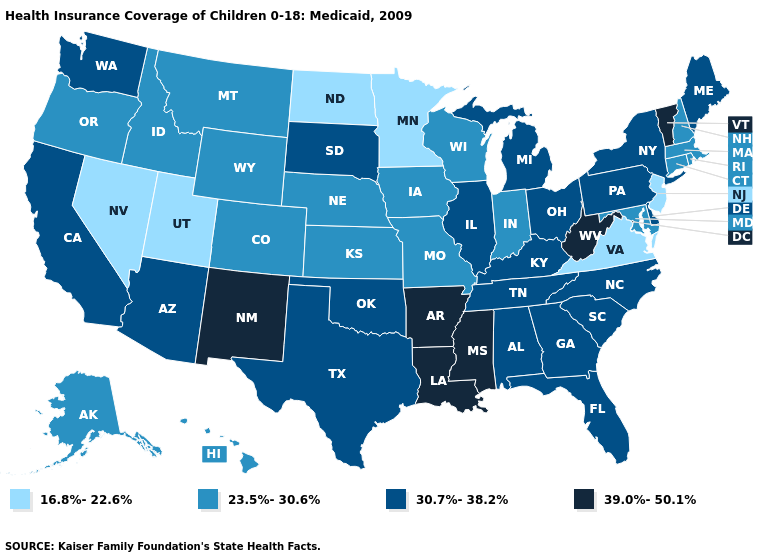Does the map have missing data?
Quick response, please. No. Name the states that have a value in the range 16.8%-22.6%?
Short answer required. Minnesota, Nevada, New Jersey, North Dakota, Utah, Virginia. Does South Carolina have the lowest value in the USA?
Be succinct. No. Name the states that have a value in the range 23.5%-30.6%?
Concise answer only. Alaska, Colorado, Connecticut, Hawaii, Idaho, Indiana, Iowa, Kansas, Maryland, Massachusetts, Missouri, Montana, Nebraska, New Hampshire, Oregon, Rhode Island, Wisconsin, Wyoming. What is the value of Idaho?
Write a very short answer. 23.5%-30.6%. What is the highest value in states that border Kansas?
Write a very short answer. 30.7%-38.2%. Name the states that have a value in the range 30.7%-38.2%?
Write a very short answer. Alabama, Arizona, California, Delaware, Florida, Georgia, Illinois, Kentucky, Maine, Michigan, New York, North Carolina, Ohio, Oklahoma, Pennsylvania, South Carolina, South Dakota, Tennessee, Texas, Washington. How many symbols are there in the legend?
Quick response, please. 4. What is the value of Montana?
Answer briefly. 23.5%-30.6%. Name the states that have a value in the range 23.5%-30.6%?
Write a very short answer. Alaska, Colorado, Connecticut, Hawaii, Idaho, Indiana, Iowa, Kansas, Maryland, Massachusetts, Missouri, Montana, Nebraska, New Hampshire, Oregon, Rhode Island, Wisconsin, Wyoming. Name the states that have a value in the range 30.7%-38.2%?
Concise answer only. Alabama, Arizona, California, Delaware, Florida, Georgia, Illinois, Kentucky, Maine, Michigan, New York, North Carolina, Ohio, Oklahoma, Pennsylvania, South Carolina, South Dakota, Tennessee, Texas, Washington. What is the lowest value in states that border Minnesota?
Be succinct. 16.8%-22.6%. Which states have the highest value in the USA?
Answer briefly. Arkansas, Louisiana, Mississippi, New Mexico, Vermont, West Virginia. 